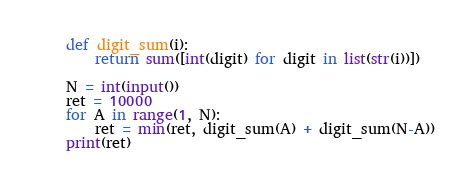<code> <loc_0><loc_0><loc_500><loc_500><_Python_>def digit_sum(i):
    return sum([int(digit) for digit in list(str(i))])

N = int(input())
ret = 10000
for A in range(1, N):
    ret = min(ret, digit_sum(A) + digit_sum(N-A))
print(ret)</code> 